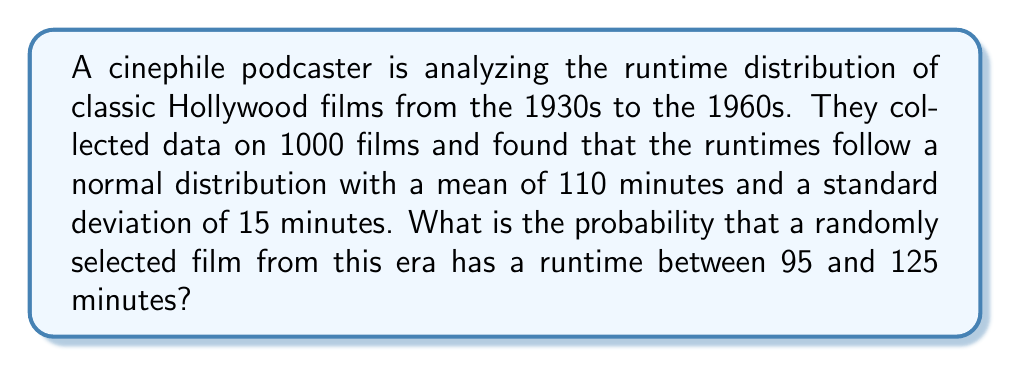Can you solve this math problem? To solve this problem, we need to use the properties of the normal distribution and the concept of z-scores.

Step 1: Identify the given information
- The distribution is normal
- Mean (μ) = 110 minutes
- Standard deviation (σ) = 15 minutes
- We want the probability of a film having a runtime between 95 and 125 minutes

Step 2: Calculate the z-scores for the lower and upper bounds
Lower bound z-score:
$$ z_1 = \frac{x_1 - \mu}{\sigma} = \frac{95 - 110}{15} = -1 $$

Upper bound z-score:
$$ z_2 = \frac{x_2 - \mu}{\sigma} = \frac{125 - 110}{15} = 1 $$

Step 3: Use the standard normal distribution table or a calculator to find the area between these z-scores
The area between z = -1 and z = 1 in a standard normal distribution is approximately 0.6826 or 68.26%.

Step 4: Interpret the result
This means that approximately 68.26% of the films in this classic Hollywood era have runtimes between 95 and 125 minutes.
Answer: 0.6826 or 68.26% 